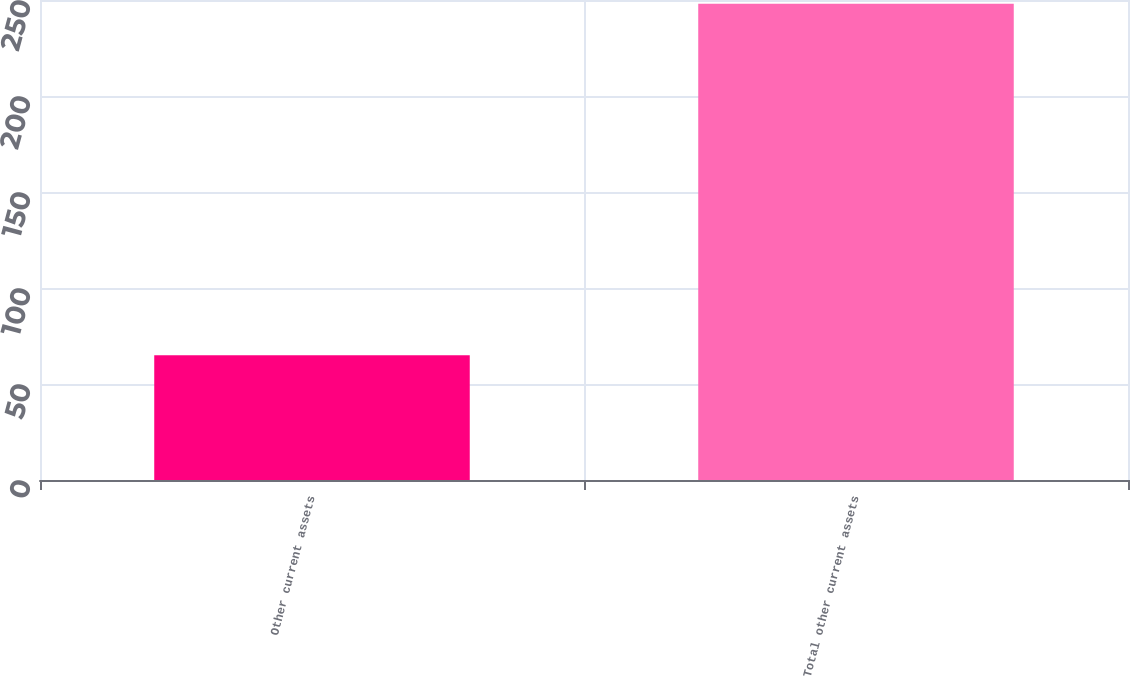Convert chart to OTSL. <chart><loc_0><loc_0><loc_500><loc_500><bar_chart><fcel>Other current assets<fcel>Total other current assets<nl><fcel>65<fcel>248<nl></chart> 